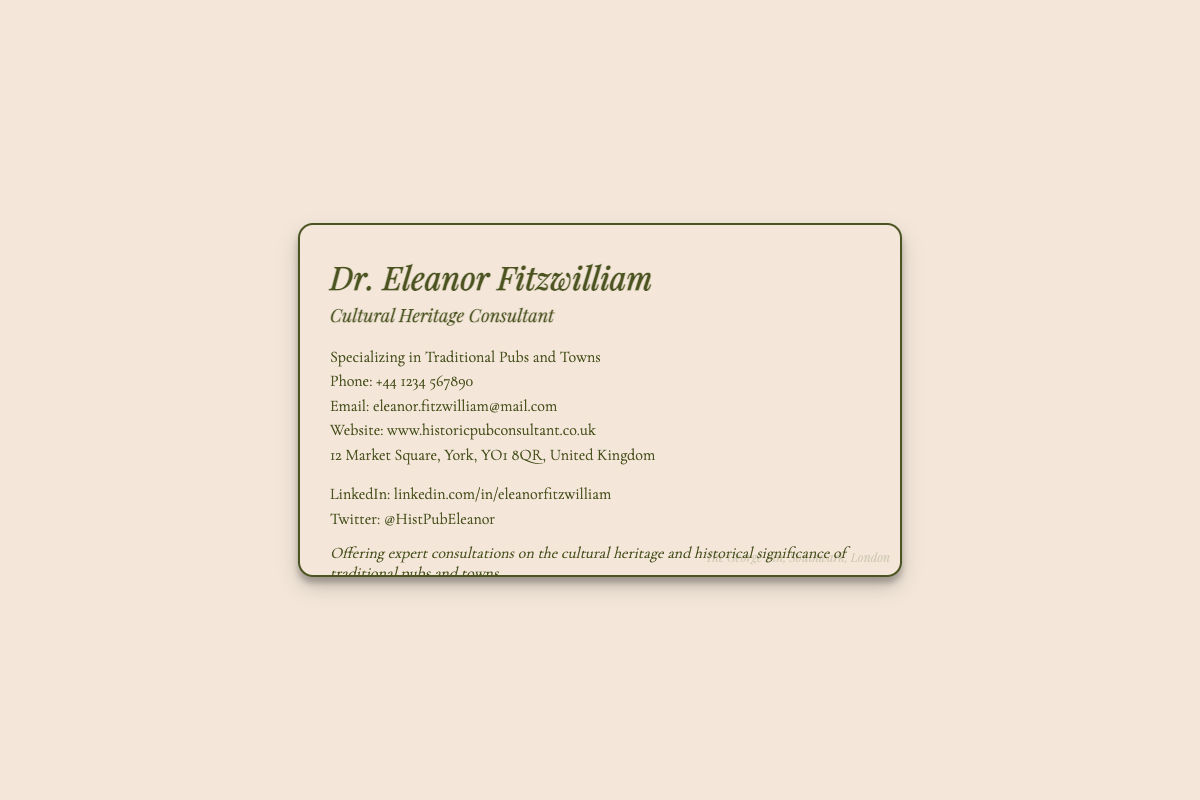What is the name of the consultant? The name of the consultant is prominently displayed at the top of the card.
Answer: Dr. Eleanor Fitzwilliam What is Dr. Eleanor Fitzwilliam's profession? The profession of Dr. Eleanor Fitzwilliam is indicated clearly under her name.
Answer: Cultural Heritage Consultant What town is Dr. Eleanor based in? The address provided on the card includes the town where Dr. Eleanor is located.
Answer: York What is Dr. Eleanor's phone number? The contact number is stated clearly in a specific format on the card.
Answer: +44 1234 567890 What social media platforms are mentioned? The card lists two social media accounts for Dr. Eleanor.
Answer: LinkedIn and Twitter What is the expertise area mentioned? The expertise area is described in a sentence on the card, indicating her specialization.
Answer: Traditional Pubs and Towns What is the subtle watermark on the card? The watermark provides an iconic reference to a well-known historical pub, mentioned at the bottom.
Answer: The George Inn, Southwark, London How is the content of the card organized? The card structure includes a title, professional title, contact information, and social handles.
Answer: Hierarchical format What is the website for Dr. Eleanor Fitzwilliam? A specific URL is provided on the card for those seeking more information about her services.
Answer: www.historicpubconsultant.co.uk 